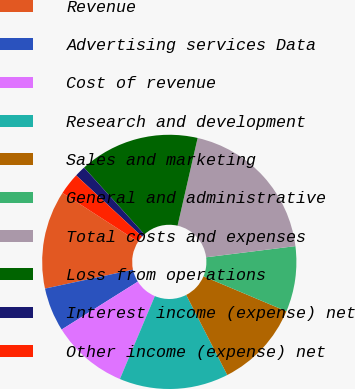Convert chart to OTSL. <chart><loc_0><loc_0><loc_500><loc_500><pie_chart><fcel>Revenue<fcel>Advertising services Data<fcel>Cost of revenue<fcel>Research and development<fcel>Sales and marketing<fcel>General and administrative<fcel>Total costs and expenses<fcel>Loss from operations<fcel>Interest income (expense) net<fcel>Other income (expense) net<nl><fcel>12.5%<fcel>5.56%<fcel>9.72%<fcel>13.89%<fcel>11.11%<fcel>8.33%<fcel>19.44%<fcel>15.28%<fcel>1.39%<fcel>2.78%<nl></chart> 